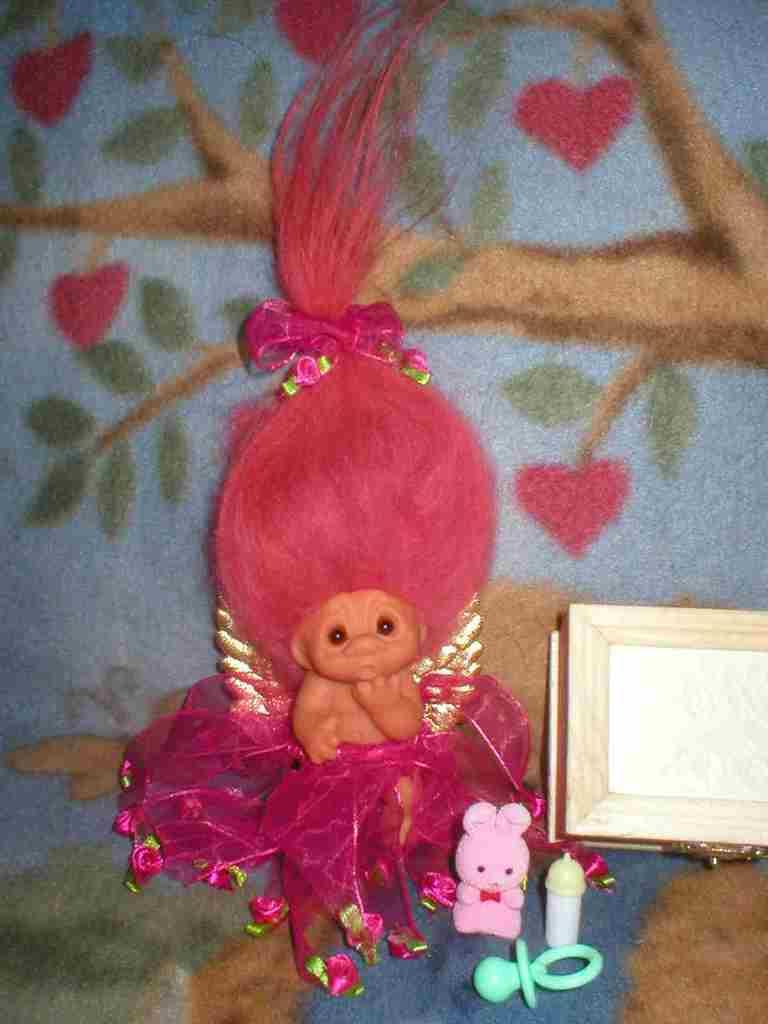What is the main subject of the image? There is a doll in the image. What else can be seen in the image besides the doll? There are toys and a box visible in the image. Where are the doll, toys, and box located? They are on a cloth in the image. What is the price of the sand in the image? There is no sand present in the image, so it is not possible to determine its price. 